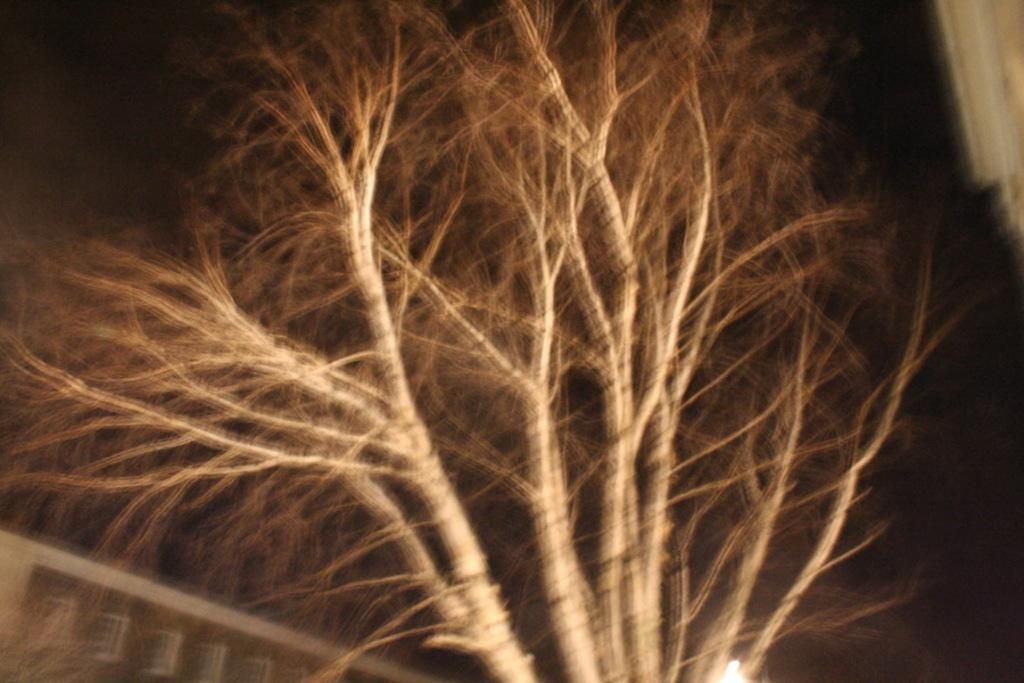What type of tree is depicted in the image? There is a dried tree in the image. How would you describe the overall appearance of the image? The image has a dark appearance. What type of mitten is hanging on the dried tree in the image? There is no mitten present in the image; it only features a dried tree. Can you hear a whistle in the image? There is no sound in the image, so it is not possible to hear a whistle. 